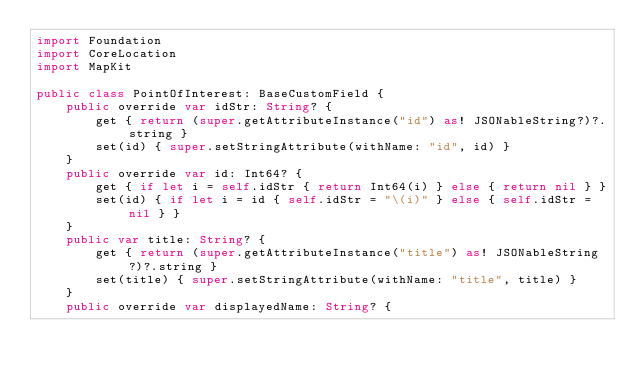<code> <loc_0><loc_0><loc_500><loc_500><_Swift_>import Foundation
import CoreLocation
import MapKit

public class PointOfInterest: BaseCustomField {
    public override var idStr: String? {
        get { return (super.getAttributeInstance("id") as! JSONableString?)?.string }
        set(id) { super.setStringAttribute(withName: "id", id) }
    }
    public override var id: Int64? {
        get { if let i = self.idStr { return Int64(i) } else { return nil } }
        set(id) { if let i = id { self.idStr = "\(i)" } else { self.idStr = nil } }
    }
    public var title: String? {
        get { return (super.getAttributeInstance("title") as! JSONableString?)?.string }
        set(title) { super.setStringAttribute(withName: "title", title) }
    }
    public override var displayedName: String? {</code> 